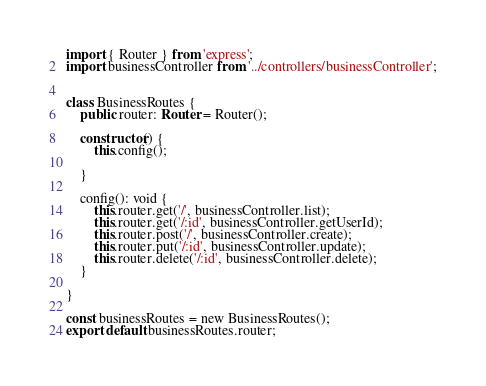Convert code to text. <code><loc_0><loc_0><loc_500><loc_500><_TypeScript_>import { Router } from 'express';
import businessController from '../controllers/businessController';


class BusinessRoutes {
    public router: Router = Router();

    constructor() {
        this.config();

    }

    config(): void {
        this.router.get('/', businessController.list);
        this.router.get('/:id', businessController.getUserId);
        this.router.post('/', businessController.create);
        this.router.put('/:id', businessController.update);
        this.router.delete('/:id', businessController.delete);
    }

}

const businessRoutes = new BusinessRoutes();
export default businessRoutes.router;</code> 